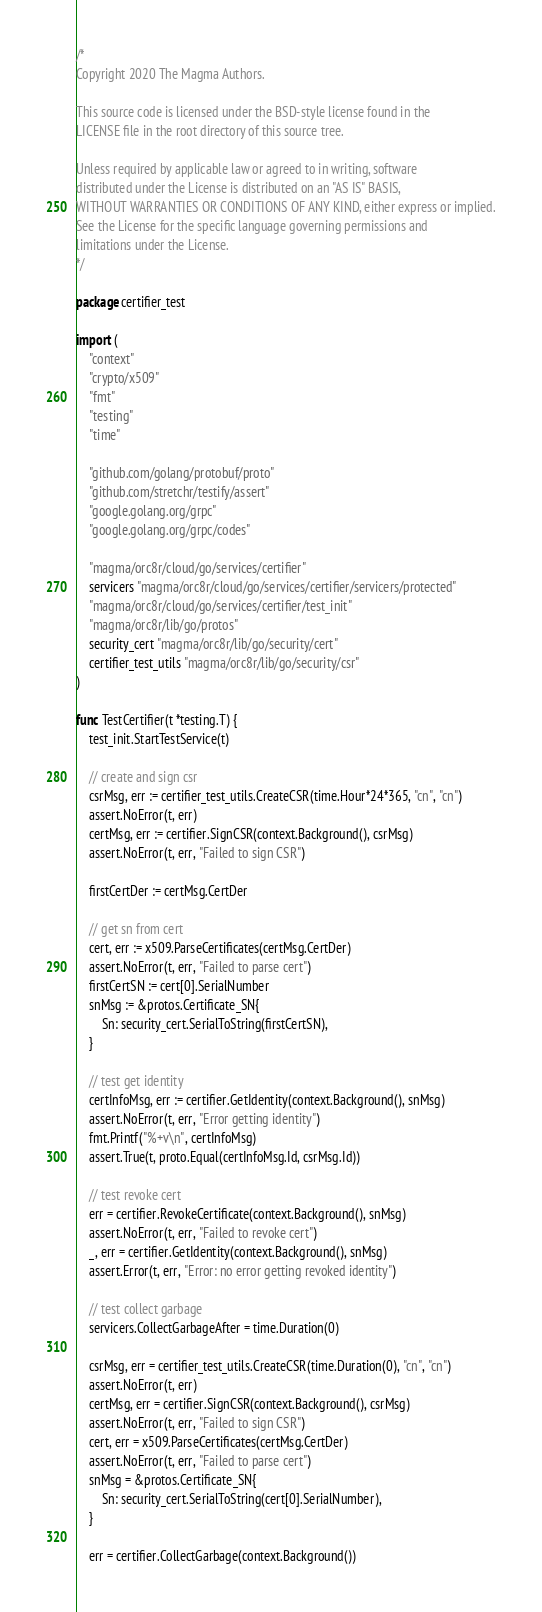<code> <loc_0><loc_0><loc_500><loc_500><_Go_>/*
Copyright 2020 The Magma Authors.

This source code is licensed under the BSD-style license found in the
LICENSE file in the root directory of this source tree.

Unless required by applicable law or agreed to in writing, software
distributed under the License is distributed on an "AS IS" BASIS,
WITHOUT WARRANTIES OR CONDITIONS OF ANY KIND, either express or implied.
See the License for the specific language governing permissions and
limitations under the License.
*/

package certifier_test

import (
	"context"
	"crypto/x509"
	"fmt"
	"testing"
	"time"

	"github.com/golang/protobuf/proto"
	"github.com/stretchr/testify/assert"
	"google.golang.org/grpc"
	"google.golang.org/grpc/codes"

	"magma/orc8r/cloud/go/services/certifier"
	servicers "magma/orc8r/cloud/go/services/certifier/servicers/protected"
	"magma/orc8r/cloud/go/services/certifier/test_init"
	"magma/orc8r/lib/go/protos"
	security_cert "magma/orc8r/lib/go/security/cert"
	certifier_test_utils "magma/orc8r/lib/go/security/csr"
)

func TestCertifier(t *testing.T) {
	test_init.StartTestService(t)

	// create and sign csr
	csrMsg, err := certifier_test_utils.CreateCSR(time.Hour*24*365, "cn", "cn")
	assert.NoError(t, err)
	certMsg, err := certifier.SignCSR(context.Background(), csrMsg)
	assert.NoError(t, err, "Failed to sign CSR")

	firstCertDer := certMsg.CertDer

	// get sn from cert
	cert, err := x509.ParseCertificates(certMsg.CertDer)
	assert.NoError(t, err, "Failed to parse cert")
	firstCertSN := cert[0].SerialNumber
	snMsg := &protos.Certificate_SN{
		Sn: security_cert.SerialToString(firstCertSN),
	}

	// test get identity
	certInfoMsg, err := certifier.GetIdentity(context.Background(), snMsg)
	assert.NoError(t, err, "Error getting identity")
	fmt.Printf("%+v\n", certInfoMsg)
	assert.True(t, proto.Equal(certInfoMsg.Id, csrMsg.Id))

	// test revoke cert
	err = certifier.RevokeCertificate(context.Background(), snMsg)
	assert.NoError(t, err, "Failed to revoke cert")
	_, err = certifier.GetIdentity(context.Background(), snMsg)
	assert.Error(t, err, "Error: no error getting revoked identity")

	// test collect garbage
	servicers.CollectGarbageAfter = time.Duration(0)

	csrMsg, err = certifier_test_utils.CreateCSR(time.Duration(0), "cn", "cn")
	assert.NoError(t, err)
	certMsg, err = certifier.SignCSR(context.Background(), csrMsg)
	assert.NoError(t, err, "Failed to sign CSR")
	cert, err = x509.ParseCertificates(certMsg.CertDer)
	assert.NoError(t, err, "Failed to parse cert")
	snMsg = &protos.Certificate_SN{
		Sn: security_cert.SerialToString(cert[0].SerialNumber),
	}

	err = certifier.CollectGarbage(context.Background())</code> 